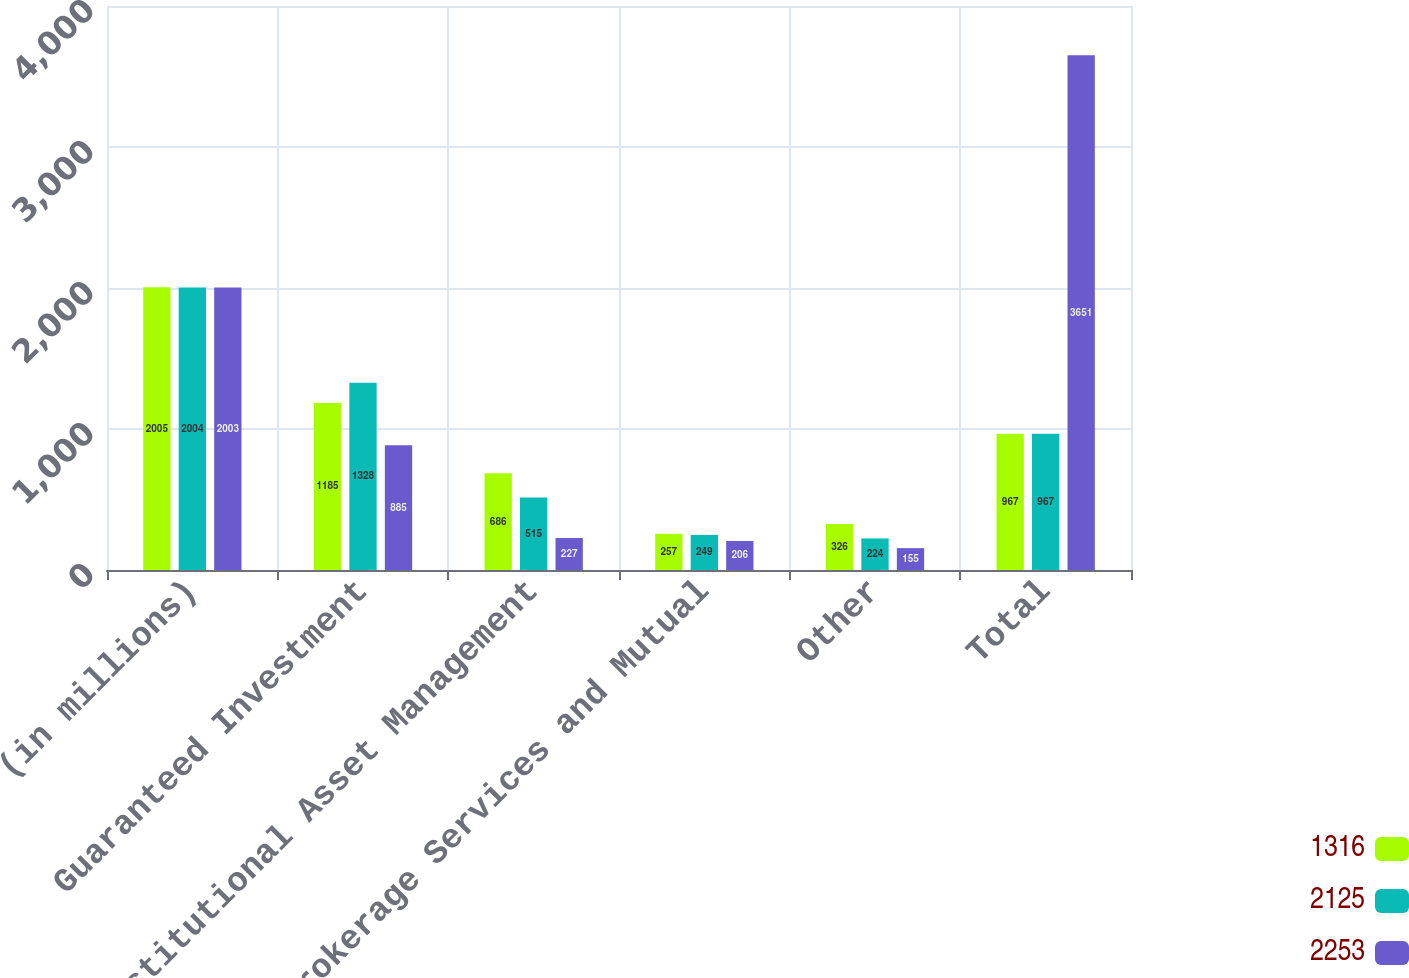Convert chart. <chart><loc_0><loc_0><loc_500><loc_500><stacked_bar_chart><ecel><fcel>(in millions)<fcel>Guaranteed Investment<fcel>Institutional Asset Management<fcel>Brokerage Services and Mutual<fcel>Other<fcel>Total<nl><fcel>1316<fcel>2005<fcel>1185<fcel>686<fcel>257<fcel>326<fcel>967<nl><fcel>2125<fcel>2004<fcel>1328<fcel>515<fcel>249<fcel>224<fcel>967<nl><fcel>2253<fcel>2003<fcel>885<fcel>227<fcel>206<fcel>155<fcel>3651<nl></chart> 